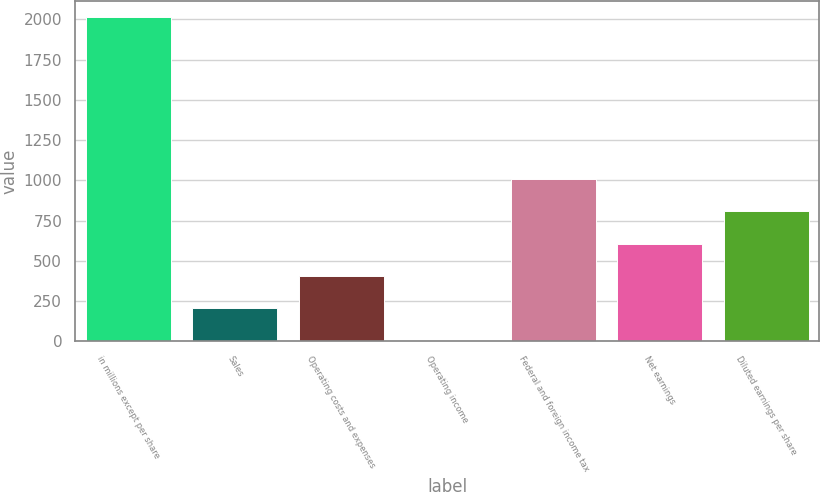Convert chart. <chart><loc_0><loc_0><loc_500><loc_500><bar_chart><fcel>in millions except per share<fcel>Sales<fcel>Operating costs and expenses<fcel>Operating income<fcel>Federal and foreign income tax<fcel>Net earnings<fcel>Diluted earnings per share<nl><fcel>2017<fcel>203.5<fcel>405<fcel>2<fcel>1009.5<fcel>606.5<fcel>808<nl></chart> 